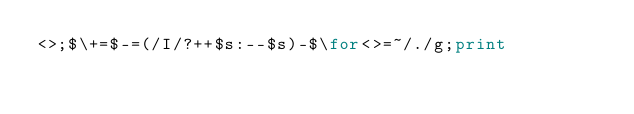<code> <loc_0><loc_0><loc_500><loc_500><_Perl_><>;$\+=$-=(/I/?++$s:--$s)-$\for<>=~/./g;print</code> 